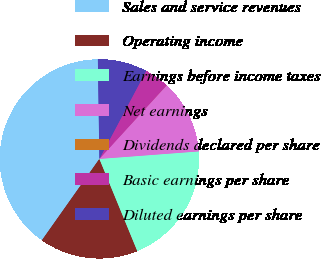Convert chart to OTSL. <chart><loc_0><loc_0><loc_500><loc_500><pie_chart><fcel>Sales and service revenues<fcel>Operating income<fcel>Earnings before income taxes<fcel>Net earnings<fcel>Dividends declared per share<fcel>Basic earnings per share<fcel>Diluted earnings per share<nl><fcel>39.97%<fcel>16.0%<fcel>19.99%<fcel>12.0%<fcel>0.02%<fcel>4.01%<fcel>8.01%<nl></chart> 